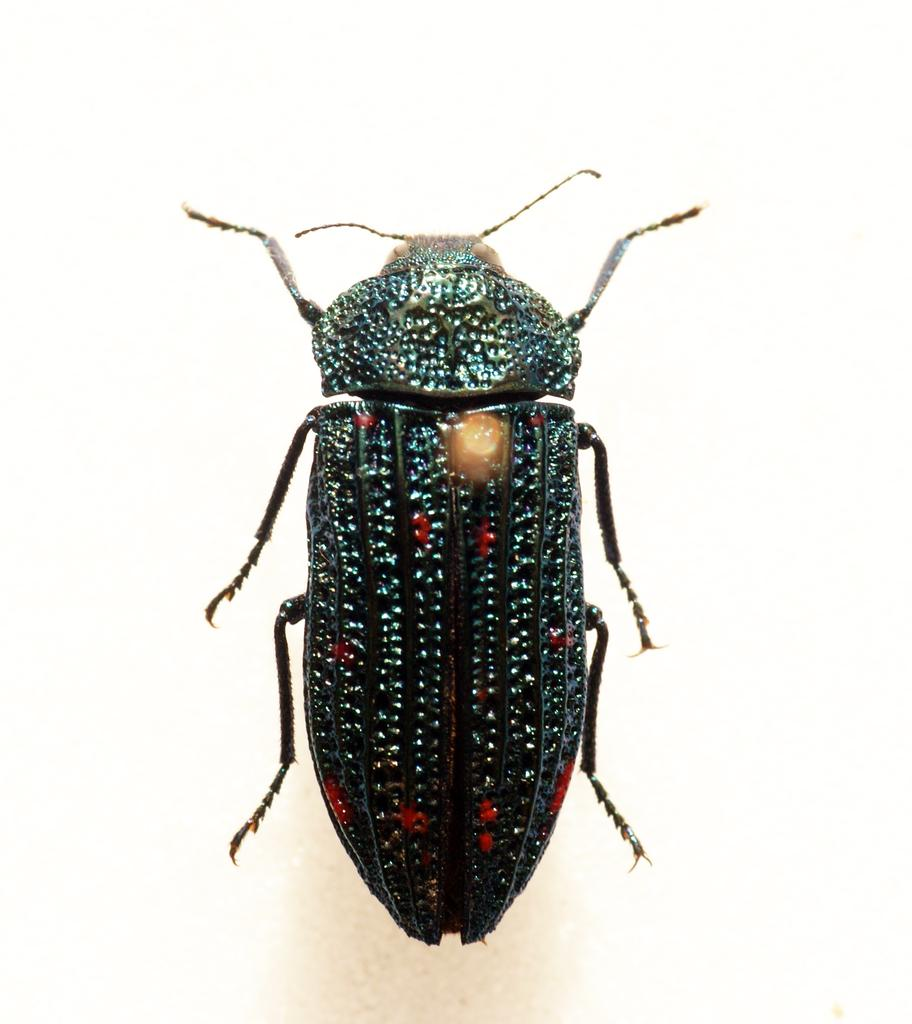What type of creature is present in the image? There is an insect in the image. What is the color of the insect? The insect is black in color. How many legs does the insect have? The insect has six legs. What other features can be observed on the insect? The insect has two antennas. What is the color of the background in the image? The background of the image is white in color. Can you tell me how many baskets are visible in the image? There are no baskets present in the image. What type of jar is the insect sitting on in the image? There is no jar present in the image; the insect is not sitting on anything. 